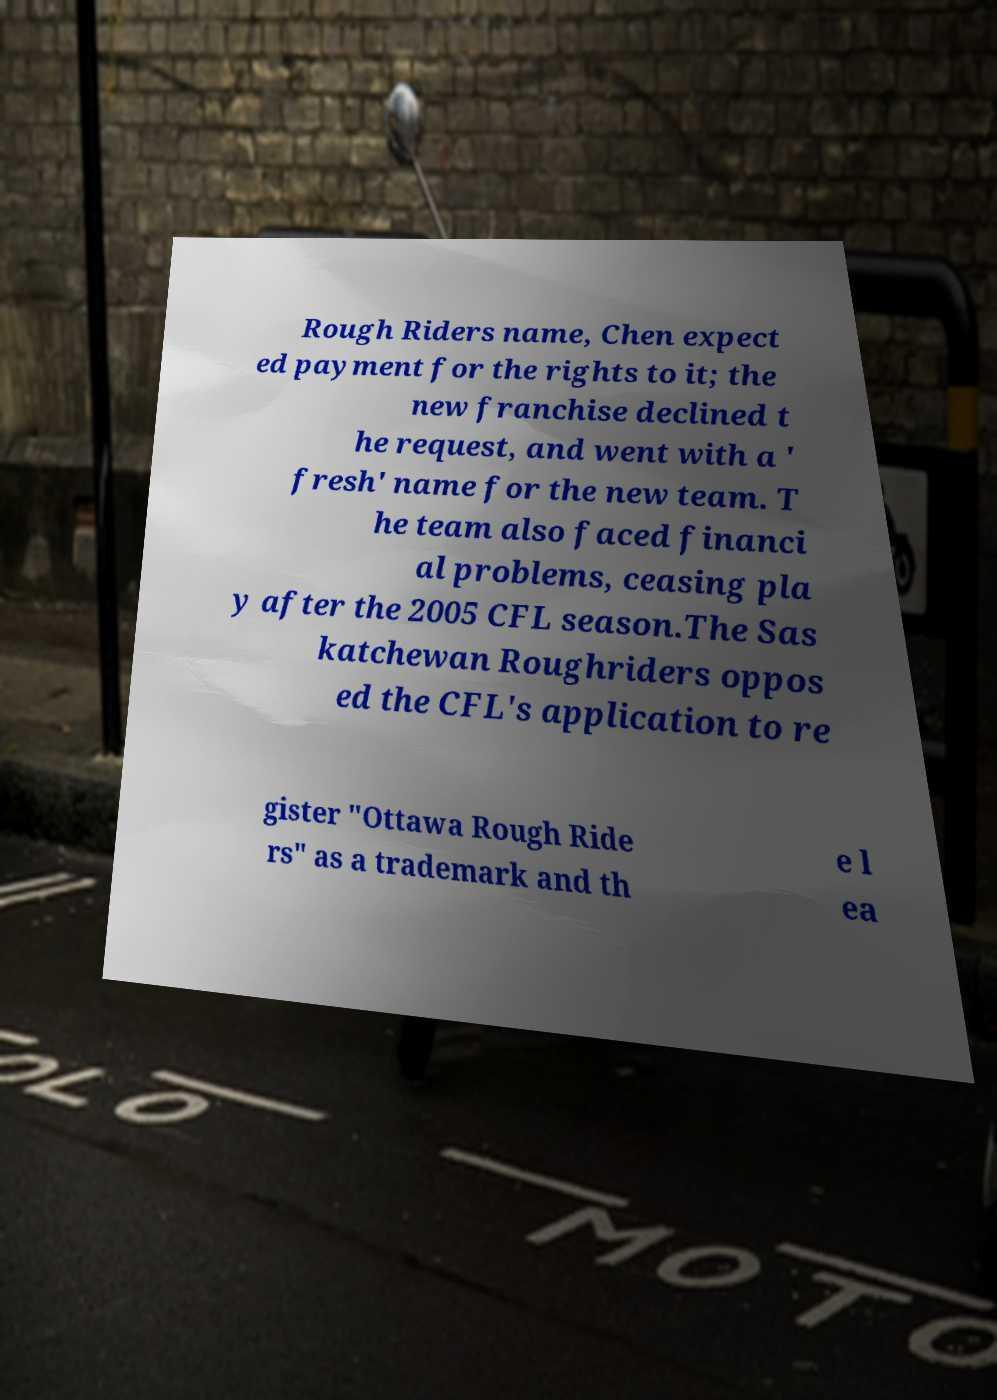What messages or text are displayed in this image? I need them in a readable, typed format. Rough Riders name, Chen expect ed payment for the rights to it; the new franchise declined t he request, and went with a ' fresh' name for the new team. T he team also faced financi al problems, ceasing pla y after the 2005 CFL season.The Sas katchewan Roughriders oppos ed the CFL's application to re gister "Ottawa Rough Ride rs" as a trademark and th e l ea 